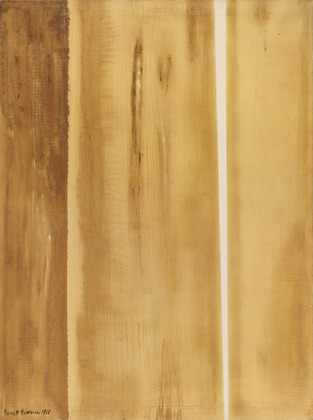Relate this painting to a real-life scenario for illustrative purposes. Imagine walking through an ancient forest at dawn. The first light of the sun filters through the towering trees, casting long shadows and illuminating the rich, earthy tones of the forest floor. The air is filled with the scent of damp earth and the sound of rustling leaves. This scene mirrors the painting, where the vertical lines represent the trees and the warm hues depict the soft, golden light of the morning.  Now relate the painting to a different real-life scenario. Picture yourself in an arid desert right before dusk. The vertical lines in the painting could be the tall cliffs and rock formations that define the landscape. The warm, earthy colors reflect the golden hour light that washes over everything, creating a serene and almost mystical atmosphere. The rough textures in the painting mirror the rugged surface of the rocks, worn down by years of exposure to the elements. 